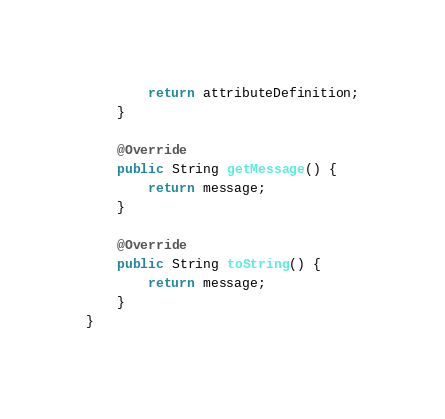<code> <loc_0><loc_0><loc_500><loc_500><_Java_>		return attributeDefinition;
	}

	@Override
	public String getMessage() {
		return message;
	}

	@Override
	public String toString() {
		return message;
	}
}
</code> 